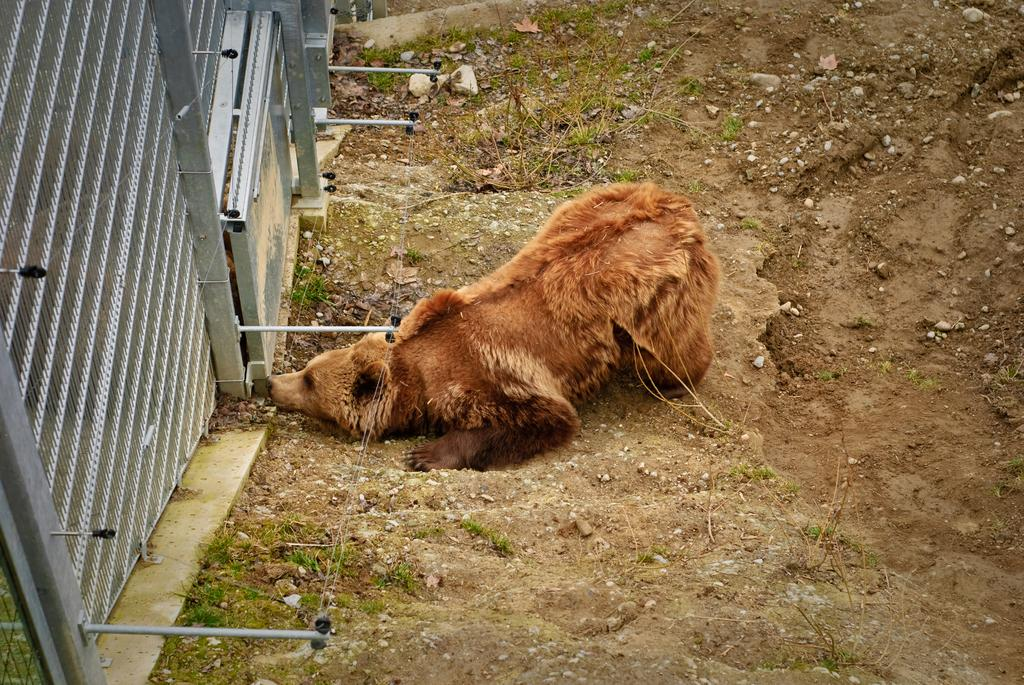What type of animal is in the image? The type of animal cannot be determined from the provided facts. What is the mesh used for in the image? The purpose of the mesh cannot be determined from the provided facts. Can you hear the whistle in the image? There is no mention of a whistle in the image, so it cannot be heard. Is there a volleyball being played in the image? There is no mention of a volleyball or any sports activity in the image. 